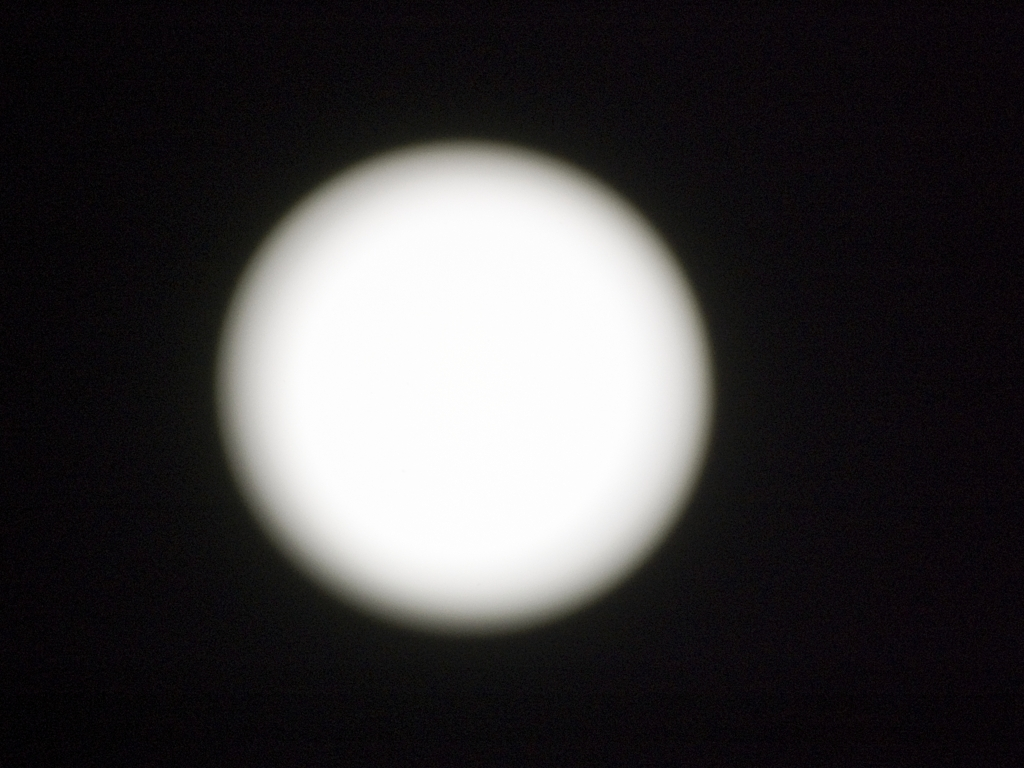What details are visible in the lunar craters? Due to the overexposure and lack of focus in the image, no specific details of the lunar craters can be discerned. A clearer image with higher resolution and better exposure might reveal the intricate patterns of the lunar surface, including craters, ridges, and possible signs of lunar activity. 